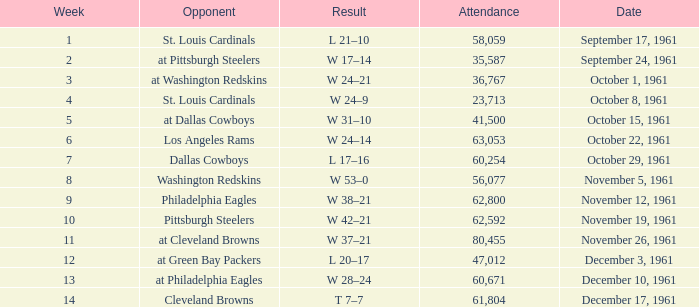Which Week has an Opponent of washington redskins, and an Attendance larger than 56,077? 0.0. 